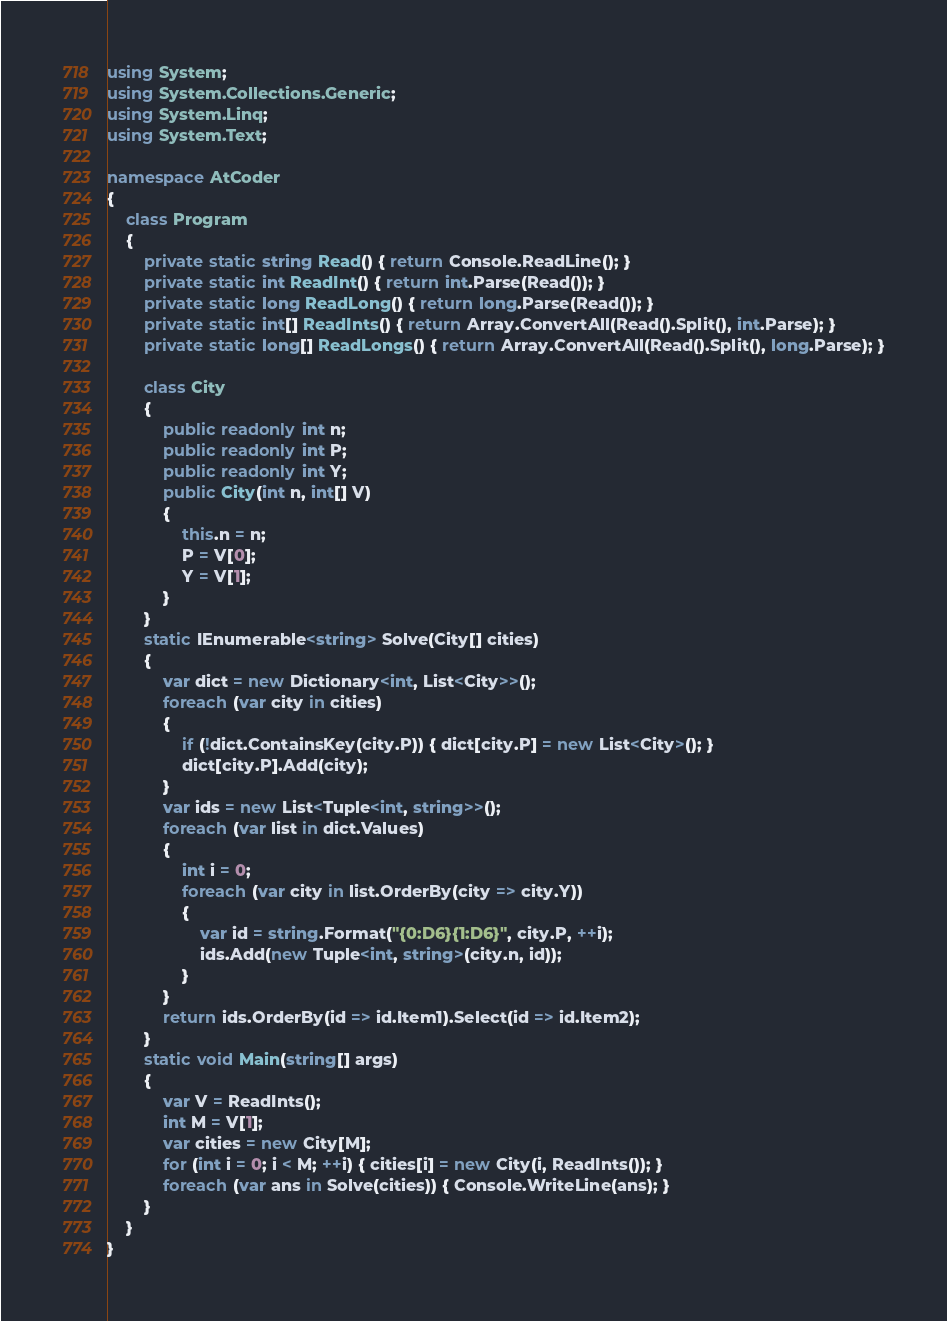Convert code to text. <code><loc_0><loc_0><loc_500><loc_500><_C#_>using System;
using System.Collections.Generic;
using System.Linq;
using System.Text;

namespace AtCoder
{
    class Program
    {
        private static string Read() { return Console.ReadLine(); }
        private static int ReadInt() { return int.Parse(Read()); }
        private static long ReadLong() { return long.Parse(Read()); }
        private static int[] ReadInts() { return Array.ConvertAll(Read().Split(), int.Parse); }
        private static long[] ReadLongs() { return Array.ConvertAll(Read().Split(), long.Parse); }

        class City
        {
            public readonly int n;
            public readonly int P;
            public readonly int Y;
            public City(int n, int[] V)
            {
                this.n = n;
                P = V[0];
                Y = V[1];
            }
        }
        static IEnumerable<string> Solve(City[] cities)
        {
            var dict = new Dictionary<int, List<City>>();
            foreach (var city in cities)
            {
                if (!dict.ContainsKey(city.P)) { dict[city.P] = new List<City>(); }
                dict[city.P].Add(city);
            }
            var ids = new List<Tuple<int, string>>();
            foreach (var list in dict.Values)
            {
                int i = 0;
                foreach (var city in list.OrderBy(city => city.Y))
                {
                    var id = string.Format("{0:D6}{1:D6}", city.P, ++i);
                    ids.Add(new Tuple<int, string>(city.n, id));
                }
            }
            return ids.OrderBy(id => id.Item1).Select(id => id.Item2);
        }
        static void Main(string[] args)
        {
            var V = ReadInts();
            int M = V[1];
            var cities = new City[M];
            for (int i = 0; i < M; ++i) { cities[i] = new City(i, ReadInts()); }
            foreach (var ans in Solve(cities)) { Console.WriteLine(ans); }
        }
    }
}</code> 